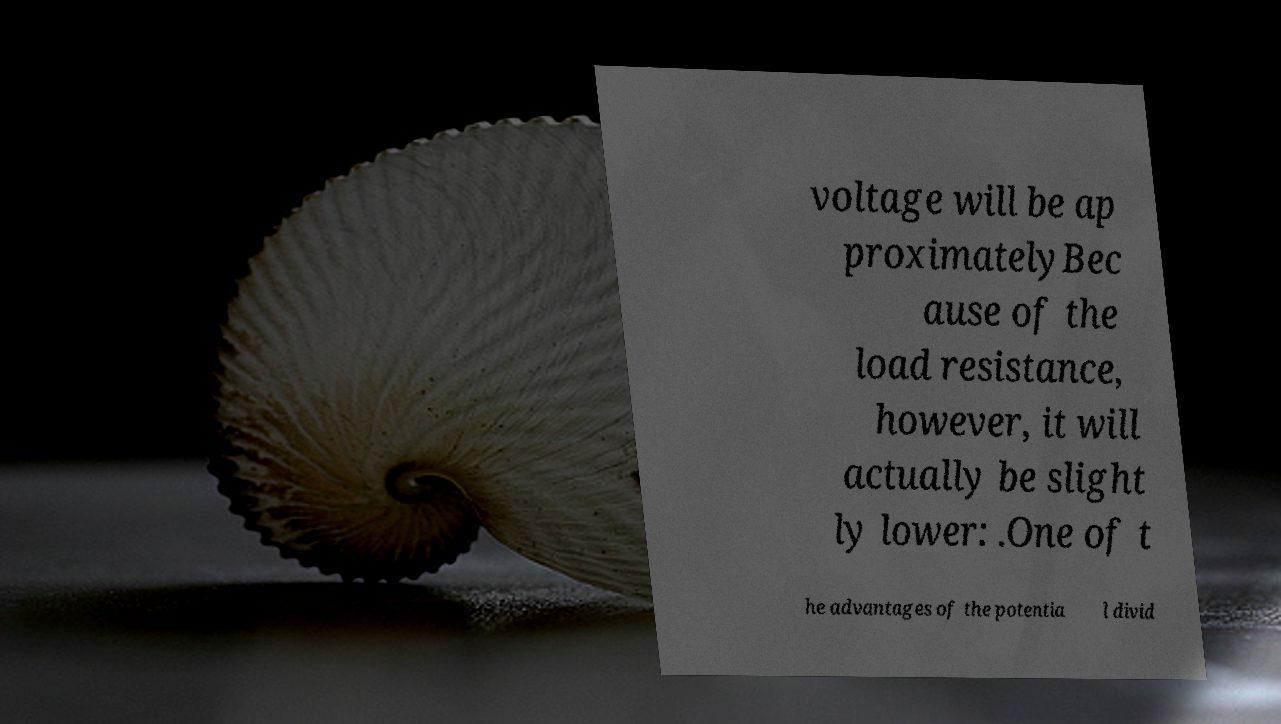Can you read and provide the text displayed in the image?This photo seems to have some interesting text. Can you extract and type it out for me? voltage will be ap proximatelyBec ause of the load resistance, however, it will actually be slight ly lower: .One of t he advantages of the potentia l divid 